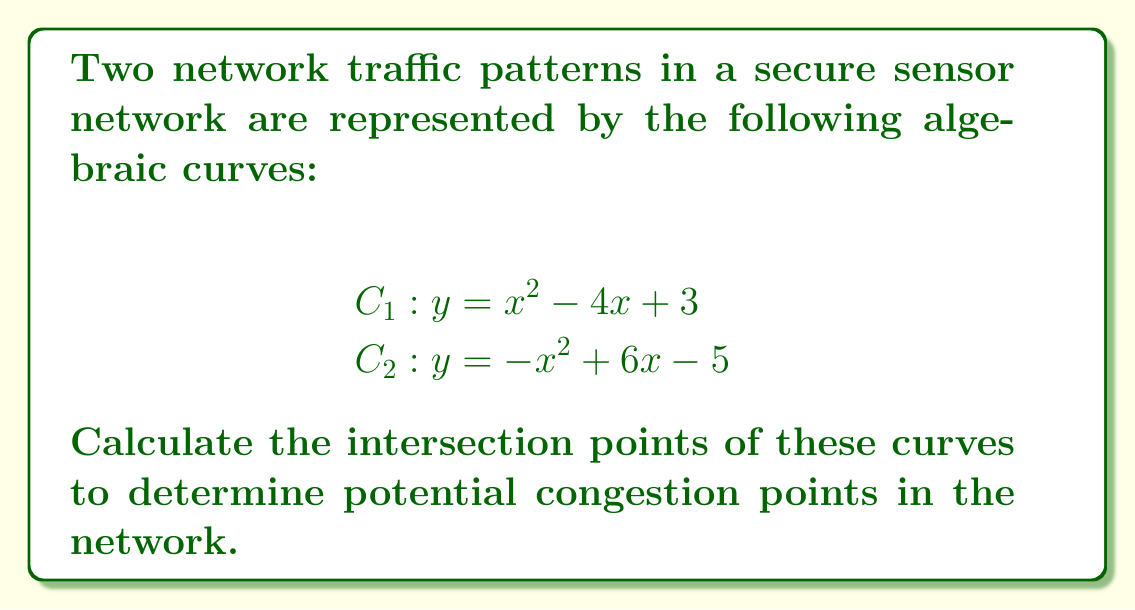Help me with this question. To find the intersection points, we need to solve the system of equations:

1) Set the equations equal to each other:
   $$x^2 - 4x + 3 = -x^2 + 6x - 5$$

2) Rearrange all terms to one side:
   $$2x^2 - 10x + 8 = 0$$

3) Divide all terms by 2:
   $$x^2 - 5x + 4 = 0$$

4) This is a quadratic equation. We can solve it using the quadratic formula:
   $$x = \frac{-b \pm \sqrt{b^2 - 4ac}}{2a}$$
   where $a=1$, $b=-5$, and $c=4$

5) Substituting these values:
   $$x = \frac{5 \pm \sqrt{25 - 16}}{2} = \frac{5 \pm 3}{2}$$

6) This gives us two solutions:
   $$x_1 = \frac{5 + 3}{2} = 4$$
   $$x_2 = \frac{5 - 3}{2} = 1$$

7) To find the corresponding y-values, we can substitute these x-values into either of the original equations. Let's use $C_1: y = x^2 - 4x + 3$

   For $x_1 = 4$:
   $$y_1 = 4^2 - 4(4) + 3 = 16 - 16 + 3 = 3$$

   For $x_2 = 1$:
   $$y_2 = 1^2 - 4(1) + 3 = 1 - 4 + 3 = 0$$

Therefore, the intersection points are (4, 3) and (1, 0).
Answer: (4, 3) and (1, 0) 